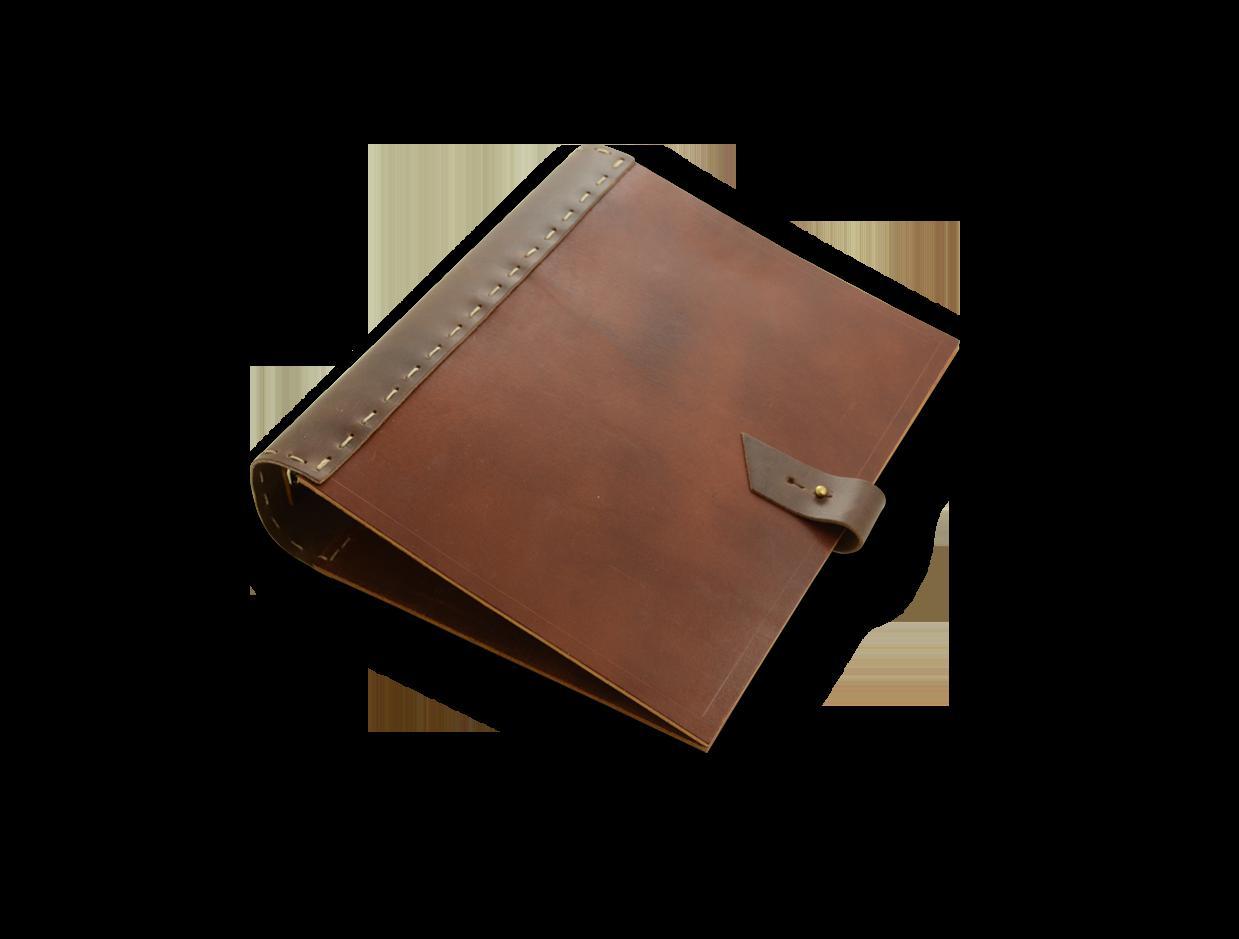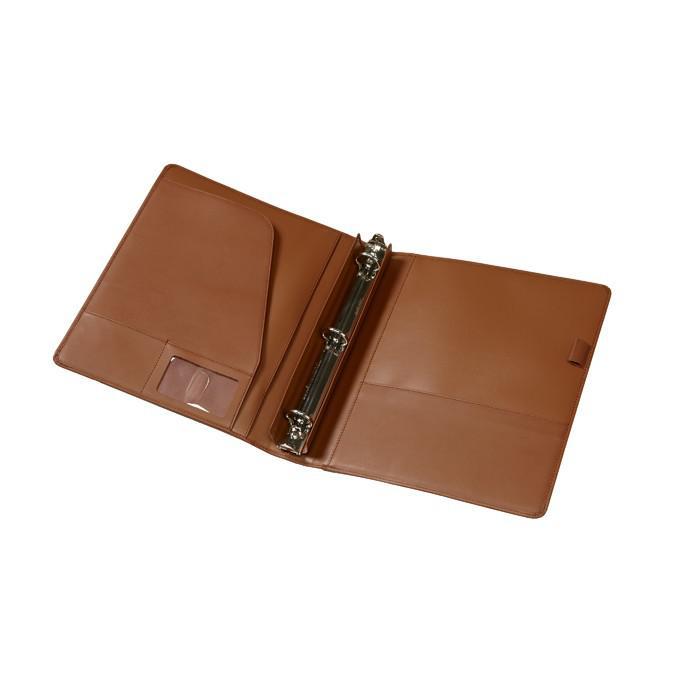The first image is the image on the left, the second image is the image on the right. Analyze the images presented: Is the assertion "Two leather binders are shown, one closed and the other open flat, showing its interior layout." valid? Answer yes or no. Yes. The first image is the image on the left, the second image is the image on the right. Assess this claim about the two images: "An image shows a single upright binder, which is dark burgundy-brownish in color.". Correct or not? Answer yes or no. No. 